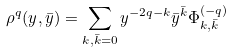<formula> <loc_0><loc_0><loc_500><loc_500>\rho ^ { q } ( y , \bar { y } ) = \sum _ { k , \bar { k } = 0 } y ^ { - 2 q - k } { \bar { y } } ^ { \bar { k } } \Phi ^ { ( - q ) } _ { k , \bar { k } }</formula> 